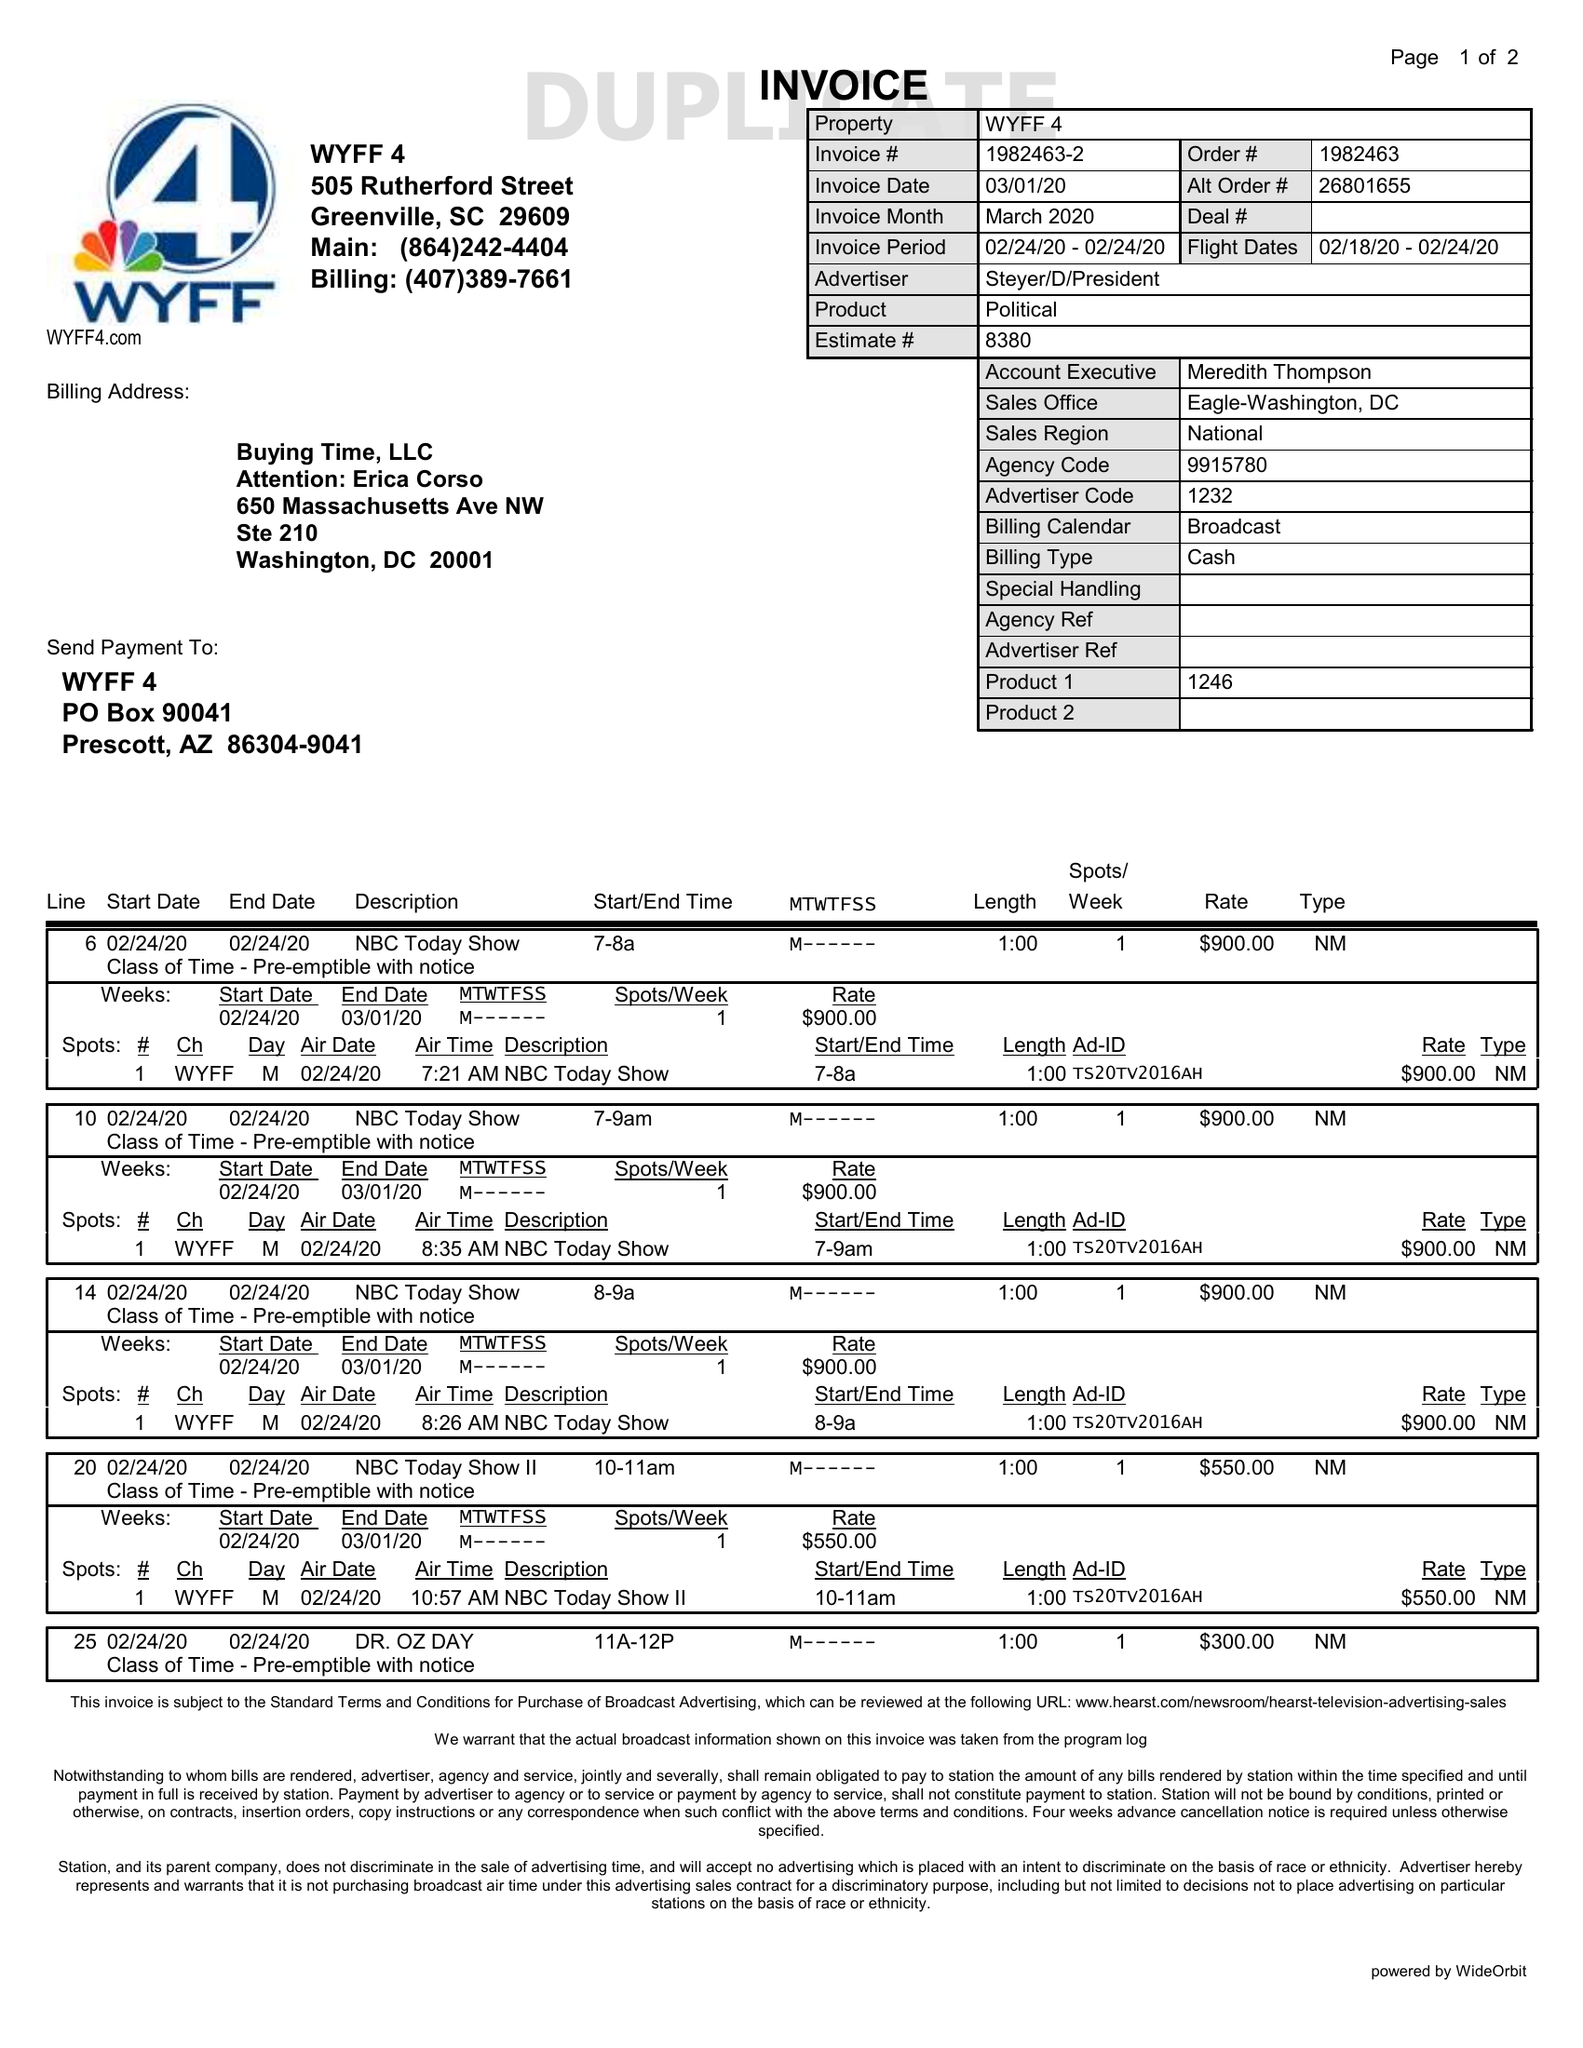What is the value for the gross_amount?
Answer the question using a single word or phrase. 4650.00 